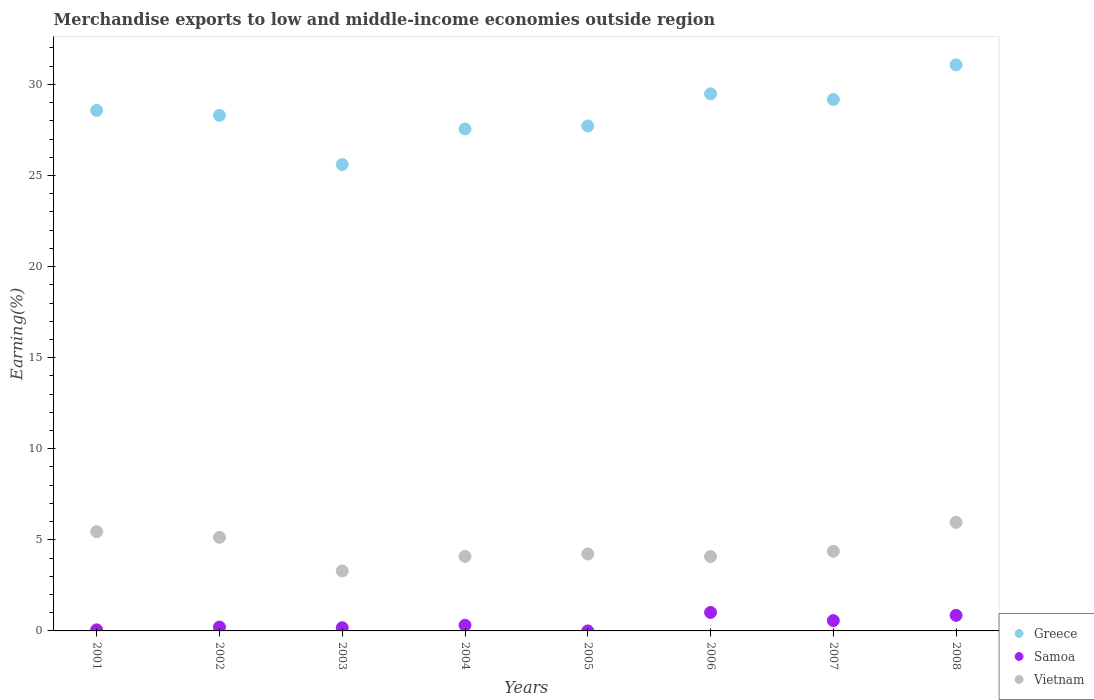How many different coloured dotlines are there?
Give a very brief answer. 3. Is the number of dotlines equal to the number of legend labels?
Keep it short and to the point. Yes. What is the percentage of amount earned from merchandise exports in Vietnam in 2004?
Make the answer very short. 4.09. Across all years, what is the maximum percentage of amount earned from merchandise exports in Greece?
Give a very brief answer. 31.07. Across all years, what is the minimum percentage of amount earned from merchandise exports in Vietnam?
Provide a short and direct response. 3.29. In which year was the percentage of amount earned from merchandise exports in Vietnam minimum?
Provide a succinct answer. 2003. What is the total percentage of amount earned from merchandise exports in Greece in the graph?
Offer a very short reply. 227.48. What is the difference between the percentage of amount earned from merchandise exports in Samoa in 2003 and that in 2007?
Your answer should be compact. -0.39. What is the difference between the percentage of amount earned from merchandise exports in Vietnam in 2004 and the percentage of amount earned from merchandise exports in Samoa in 2002?
Offer a very short reply. 3.88. What is the average percentage of amount earned from merchandise exports in Samoa per year?
Give a very brief answer. 0.4. In the year 2005, what is the difference between the percentage of amount earned from merchandise exports in Samoa and percentage of amount earned from merchandise exports in Vietnam?
Offer a very short reply. -4.22. What is the ratio of the percentage of amount earned from merchandise exports in Samoa in 2006 to that in 2008?
Offer a very short reply. 1.19. Is the difference between the percentage of amount earned from merchandise exports in Samoa in 2005 and 2006 greater than the difference between the percentage of amount earned from merchandise exports in Vietnam in 2005 and 2006?
Your answer should be very brief. No. What is the difference between the highest and the second highest percentage of amount earned from merchandise exports in Samoa?
Provide a succinct answer. 0.16. What is the difference between the highest and the lowest percentage of amount earned from merchandise exports in Vietnam?
Keep it short and to the point. 2.67. Is the sum of the percentage of amount earned from merchandise exports in Greece in 2004 and 2005 greater than the maximum percentage of amount earned from merchandise exports in Samoa across all years?
Offer a very short reply. Yes. Is the percentage of amount earned from merchandise exports in Greece strictly greater than the percentage of amount earned from merchandise exports in Vietnam over the years?
Keep it short and to the point. Yes. Is the percentage of amount earned from merchandise exports in Greece strictly less than the percentage of amount earned from merchandise exports in Samoa over the years?
Offer a very short reply. No. How many dotlines are there?
Your answer should be very brief. 3. How many years are there in the graph?
Offer a very short reply. 8. Does the graph contain any zero values?
Offer a very short reply. No. Does the graph contain grids?
Your answer should be compact. No. Where does the legend appear in the graph?
Your answer should be compact. Bottom right. How are the legend labels stacked?
Your answer should be very brief. Vertical. What is the title of the graph?
Give a very brief answer. Merchandise exports to low and middle-income economies outside region. Does "Serbia" appear as one of the legend labels in the graph?
Give a very brief answer. No. What is the label or title of the X-axis?
Your response must be concise. Years. What is the label or title of the Y-axis?
Make the answer very short. Earning(%). What is the Earning(%) in Greece in 2001?
Ensure brevity in your answer.  28.57. What is the Earning(%) in Samoa in 2001?
Provide a succinct answer. 0.06. What is the Earning(%) of Vietnam in 2001?
Your answer should be compact. 5.45. What is the Earning(%) of Greece in 2002?
Your answer should be compact. 28.3. What is the Earning(%) in Samoa in 2002?
Give a very brief answer. 0.21. What is the Earning(%) of Vietnam in 2002?
Give a very brief answer. 5.14. What is the Earning(%) in Greece in 2003?
Ensure brevity in your answer.  25.6. What is the Earning(%) of Samoa in 2003?
Give a very brief answer. 0.18. What is the Earning(%) of Vietnam in 2003?
Keep it short and to the point. 3.29. What is the Earning(%) in Greece in 2004?
Make the answer very short. 27.56. What is the Earning(%) in Samoa in 2004?
Provide a short and direct response. 0.31. What is the Earning(%) in Vietnam in 2004?
Keep it short and to the point. 4.09. What is the Earning(%) of Greece in 2005?
Provide a succinct answer. 27.72. What is the Earning(%) in Samoa in 2005?
Provide a short and direct response. 4.29047548765544e-6. What is the Earning(%) of Vietnam in 2005?
Give a very brief answer. 4.22. What is the Earning(%) of Greece in 2006?
Make the answer very short. 29.48. What is the Earning(%) in Samoa in 2006?
Your answer should be compact. 1.01. What is the Earning(%) in Vietnam in 2006?
Your answer should be very brief. 4.08. What is the Earning(%) of Greece in 2007?
Keep it short and to the point. 29.17. What is the Earning(%) of Samoa in 2007?
Offer a very short reply. 0.57. What is the Earning(%) in Vietnam in 2007?
Offer a terse response. 4.37. What is the Earning(%) of Greece in 2008?
Your answer should be very brief. 31.07. What is the Earning(%) in Samoa in 2008?
Ensure brevity in your answer.  0.86. What is the Earning(%) of Vietnam in 2008?
Keep it short and to the point. 5.96. Across all years, what is the maximum Earning(%) of Greece?
Keep it short and to the point. 31.07. Across all years, what is the maximum Earning(%) in Samoa?
Make the answer very short. 1.01. Across all years, what is the maximum Earning(%) of Vietnam?
Your answer should be very brief. 5.96. Across all years, what is the minimum Earning(%) in Greece?
Provide a succinct answer. 25.6. Across all years, what is the minimum Earning(%) in Samoa?
Offer a terse response. 4.29047548765544e-6. Across all years, what is the minimum Earning(%) of Vietnam?
Offer a very short reply. 3.29. What is the total Earning(%) of Greece in the graph?
Make the answer very short. 227.48. What is the total Earning(%) of Samoa in the graph?
Your response must be concise. 3.2. What is the total Earning(%) of Vietnam in the graph?
Keep it short and to the point. 36.6. What is the difference between the Earning(%) in Greece in 2001 and that in 2002?
Your answer should be very brief. 0.27. What is the difference between the Earning(%) in Samoa in 2001 and that in 2002?
Your response must be concise. -0.15. What is the difference between the Earning(%) of Vietnam in 2001 and that in 2002?
Give a very brief answer. 0.31. What is the difference between the Earning(%) of Greece in 2001 and that in 2003?
Provide a short and direct response. 2.97. What is the difference between the Earning(%) in Samoa in 2001 and that in 2003?
Your answer should be very brief. -0.12. What is the difference between the Earning(%) of Vietnam in 2001 and that in 2003?
Keep it short and to the point. 2.16. What is the difference between the Earning(%) of Greece in 2001 and that in 2004?
Your response must be concise. 1.02. What is the difference between the Earning(%) of Samoa in 2001 and that in 2004?
Ensure brevity in your answer.  -0.25. What is the difference between the Earning(%) of Vietnam in 2001 and that in 2004?
Give a very brief answer. 1.36. What is the difference between the Earning(%) of Greece in 2001 and that in 2005?
Provide a short and direct response. 0.85. What is the difference between the Earning(%) in Samoa in 2001 and that in 2005?
Ensure brevity in your answer.  0.06. What is the difference between the Earning(%) in Vietnam in 2001 and that in 2005?
Give a very brief answer. 1.22. What is the difference between the Earning(%) of Greece in 2001 and that in 2006?
Your response must be concise. -0.91. What is the difference between the Earning(%) in Samoa in 2001 and that in 2006?
Provide a succinct answer. -0.96. What is the difference between the Earning(%) in Vietnam in 2001 and that in 2006?
Your answer should be compact. 1.37. What is the difference between the Earning(%) in Greece in 2001 and that in 2007?
Your answer should be very brief. -0.6. What is the difference between the Earning(%) of Samoa in 2001 and that in 2007?
Your answer should be compact. -0.51. What is the difference between the Earning(%) in Vietnam in 2001 and that in 2007?
Your answer should be compact. 1.08. What is the difference between the Earning(%) in Greece in 2001 and that in 2008?
Offer a terse response. -2.5. What is the difference between the Earning(%) in Samoa in 2001 and that in 2008?
Provide a succinct answer. -0.8. What is the difference between the Earning(%) of Vietnam in 2001 and that in 2008?
Your response must be concise. -0.51. What is the difference between the Earning(%) of Greece in 2002 and that in 2003?
Ensure brevity in your answer.  2.7. What is the difference between the Earning(%) of Samoa in 2002 and that in 2003?
Ensure brevity in your answer.  0.04. What is the difference between the Earning(%) in Vietnam in 2002 and that in 2003?
Your answer should be compact. 1.85. What is the difference between the Earning(%) in Greece in 2002 and that in 2004?
Your response must be concise. 0.74. What is the difference between the Earning(%) of Samoa in 2002 and that in 2004?
Your answer should be very brief. -0.1. What is the difference between the Earning(%) of Vietnam in 2002 and that in 2004?
Your answer should be compact. 1.04. What is the difference between the Earning(%) in Greece in 2002 and that in 2005?
Offer a terse response. 0.58. What is the difference between the Earning(%) of Samoa in 2002 and that in 2005?
Make the answer very short. 0.21. What is the difference between the Earning(%) of Vietnam in 2002 and that in 2005?
Make the answer very short. 0.91. What is the difference between the Earning(%) in Greece in 2002 and that in 2006?
Provide a short and direct response. -1.18. What is the difference between the Earning(%) in Samoa in 2002 and that in 2006?
Your answer should be compact. -0.8. What is the difference between the Earning(%) in Vietnam in 2002 and that in 2006?
Your answer should be compact. 1.06. What is the difference between the Earning(%) in Greece in 2002 and that in 2007?
Give a very brief answer. -0.87. What is the difference between the Earning(%) of Samoa in 2002 and that in 2007?
Provide a short and direct response. -0.35. What is the difference between the Earning(%) of Vietnam in 2002 and that in 2007?
Offer a terse response. 0.77. What is the difference between the Earning(%) of Greece in 2002 and that in 2008?
Offer a terse response. -2.77. What is the difference between the Earning(%) of Samoa in 2002 and that in 2008?
Give a very brief answer. -0.64. What is the difference between the Earning(%) of Vietnam in 2002 and that in 2008?
Your answer should be compact. -0.82. What is the difference between the Earning(%) in Greece in 2003 and that in 2004?
Offer a terse response. -1.96. What is the difference between the Earning(%) of Samoa in 2003 and that in 2004?
Ensure brevity in your answer.  -0.14. What is the difference between the Earning(%) in Vietnam in 2003 and that in 2004?
Offer a very short reply. -0.8. What is the difference between the Earning(%) of Greece in 2003 and that in 2005?
Provide a short and direct response. -2.12. What is the difference between the Earning(%) in Samoa in 2003 and that in 2005?
Offer a very short reply. 0.18. What is the difference between the Earning(%) in Vietnam in 2003 and that in 2005?
Give a very brief answer. -0.93. What is the difference between the Earning(%) in Greece in 2003 and that in 2006?
Offer a terse response. -3.88. What is the difference between the Earning(%) in Samoa in 2003 and that in 2006?
Provide a short and direct response. -0.84. What is the difference between the Earning(%) in Vietnam in 2003 and that in 2006?
Your response must be concise. -0.79. What is the difference between the Earning(%) of Greece in 2003 and that in 2007?
Provide a succinct answer. -3.57. What is the difference between the Earning(%) in Samoa in 2003 and that in 2007?
Keep it short and to the point. -0.39. What is the difference between the Earning(%) of Vietnam in 2003 and that in 2007?
Provide a short and direct response. -1.08. What is the difference between the Earning(%) in Greece in 2003 and that in 2008?
Make the answer very short. -5.47. What is the difference between the Earning(%) of Samoa in 2003 and that in 2008?
Your response must be concise. -0.68. What is the difference between the Earning(%) in Vietnam in 2003 and that in 2008?
Provide a succinct answer. -2.67. What is the difference between the Earning(%) in Greece in 2004 and that in 2005?
Your answer should be very brief. -0.16. What is the difference between the Earning(%) in Samoa in 2004 and that in 2005?
Provide a short and direct response. 0.31. What is the difference between the Earning(%) of Vietnam in 2004 and that in 2005?
Your answer should be compact. -0.13. What is the difference between the Earning(%) in Greece in 2004 and that in 2006?
Your response must be concise. -1.93. What is the difference between the Earning(%) in Samoa in 2004 and that in 2006?
Your answer should be compact. -0.7. What is the difference between the Earning(%) of Vietnam in 2004 and that in 2006?
Give a very brief answer. 0.01. What is the difference between the Earning(%) in Greece in 2004 and that in 2007?
Your answer should be compact. -1.62. What is the difference between the Earning(%) of Samoa in 2004 and that in 2007?
Ensure brevity in your answer.  -0.25. What is the difference between the Earning(%) in Vietnam in 2004 and that in 2007?
Offer a terse response. -0.28. What is the difference between the Earning(%) of Greece in 2004 and that in 2008?
Your answer should be compact. -3.51. What is the difference between the Earning(%) in Samoa in 2004 and that in 2008?
Give a very brief answer. -0.54. What is the difference between the Earning(%) in Vietnam in 2004 and that in 2008?
Make the answer very short. -1.87. What is the difference between the Earning(%) in Greece in 2005 and that in 2006?
Offer a terse response. -1.77. What is the difference between the Earning(%) of Samoa in 2005 and that in 2006?
Your answer should be compact. -1.01. What is the difference between the Earning(%) of Vietnam in 2005 and that in 2006?
Your answer should be compact. 0.14. What is the difference between the Earning(%) of Greece in 2005 and that in 2007?
Provide a short and direct response. -1.45. What is the difference between the Earning(%) in Samoa in 2005 and that in 2007?
Ensure brevity in your answer.  -0.57. What is the difference between the Earning(%) in Vietnam in 2005 and that in 2007?
Provide a short and direct response. -0.15. What is the difference between the Earning(%) of Greece in 2005 and that in 2008?
Offer a very short reply. -3.35. What is the difference between the Earning(%) in Samoa in 2005 and that in 2008?
Offer a very short reply. -0.86. What is the difference between the Earning(%) of Vietnam in 2005 and that in 2008?
Ensure brevity in your answer.  -1.73. What is the difference between the Earning(%) of Greece in 2006 and that in 2007?
Give a very brief answer. 0.31. What is the difference between the Earning(%) in Samoa in 2006 and that in 2007?
Ensure brevity in your answer.  0.45. What is the difference between the Earning(%) of Vietnam in 2006 and that in 2007?
Ensure brevity in your answer.  -0.29. What is the difference between the Earning(%) in Greece in 2006 and that in 2008?
Your answer should be very brief. -1.59. What is the difference between the Earning(%) of Samoa in 2006 and that in 2008?
Offer a very short reply. 0.16. What is the difference between the Earning(%) in Vietnam in 2006 and that in 2008?
Keep it short and to the point. -1.88. What is the difference between the Earning(%) of Greece in 2007 and that in 2008?
Your answer should be very brief. -1.9. What is the difference between the Earning(%) of Samoa in 2007 and that in 2008?
Offer a terse response. -0.29. What is the difference between the Earning(%) in Vietnam in 2007 and that in 2008?
Ensure brevity in your answer.  -1.59. What is the difference between the Earning(%) in Greece in 2001 and the Earning(%) in Samoa in 2002?
Your answer should be very brief. 28.36. What is the difference between the Earning(%) in Greece in 2001 and the Earning(%) in Vietnam in 2002?
Make the answer very short. 23.43. What is the difference between the Earning(%) of Samoa in 2001 and the Earning(%) of Vietnam in 2002?
Keep it short and to the point. -5.08. What is the difference between the Earning(%) of Greece in 2001 and the Earning(%) of Samoa in 2003?
Give a very brief answer. 28.4. What is the difference between the Earning(%) in Greece in 2001 and the Earning(%) in Vietnam in 2003?
Provide a short and direct response. 25.28. What is the difference between the Earning(%) in Samoa in 2001 and the Earning(%) in Vietnam in 2003?
Offer a very short reply. -3.23. What is the difference between the Earning(%) of Greece in 2001 and the Earning(%) of Samoa in 2004?
Give a very brief answer. 28.26. What is the difference between the Earning(%) of Greece in 2001 and the Earning(%) of Vietnam in 2004?
Make the answer very short. 24.48. What is the difference between the Earning(%) of Samoa in 2001 and the Earning(%) of Vietnam in 2004?
Provide a succinct answer. -4.03. What is the difference between the Earning(%) of Greece in 2001 and the Earning(%) of Samoa in 2005?
Provide a short and direct response. 28.57. What is the difference between the Earning(%) in Greece in 2001 and the Earning(%) in Vietnam in 2005?
Make the answer very short. 24.35. What is the difference between the Earning(%) in Samoa in 2001 and the Earning(%) in Vietnam in 2005?
Make the answer very short. -4.17. What is the difference between the Earning(%) of Greece in 2001 and the Earning(%) of Samoa in 2006?
Offer a very short reply. 27.56. What is the difference between the Earning(%) of Greece in 2001 and the Earning(%) of Vietnam in 2006?
Make the answer very short. 24.49. What is the difference between the Earning(%) in Samoa in 2001 and the Earning(%) in Vietnam in 2006?
Keep it short and to the point. -4.02. What is the difference between the Earning(%) in Greece in 2001 and the Earning(%) in Samoa in 2007?
Offer a very short reply. 28.01. What is the difference between the Earning(%) of Greece in 2001 and the Earning(%) of Vietnam in 2007?
Give a very brief answer. 24.2. What is the difference between the Earning(%) in Samoa in 2001 and the Earning(%) in Vietnam in 2007?
Keep it short and to the point. -4.31. What is the difference between the Earning(%) of Greece in 2001 and the Earning(%) of Samoa in 2008?
Provide a short and direct response. 27.72. What is the difference between the Earning(%) of Greece in 2001 and the Earning(%) of Vietnam in 2008?
Your answer should be very brief. 22.61. What is the difference between the Earning(%) in Samoa in 2001 and the Earning(%) in Vietnam in 2008?
Your response must be concise. -5.9. What is the difference between the Earning(%) of Greece in 2002 and the Earning(%) of Samoa in 2003?
Your answer should be very brief. 28.13. What is the difference between the Earning(%) in Greece in 2002 and the Earning(%) in Vietnam in 2003?
Keep it short and to the point. 25.01. What is the difference between the Earning(%) of Samoa in 2002 and the Earning(%) of Vietnam in 2003?
Keep it short and to the point. -3.08. What is the difference between the Earning(%) of Greece in 2002 and the Earning(%) of Samoa in 2004?
Give a very brief answer. 27.99. What is the difference between the Earning(%) in Greece in 2002 and the Earning(%) in Vietnam in 2004?
Your response must be concise. 24.21. What is the difference between the Earning(%) of Samoa in 2002 and the Earning(%) of Vietnam in 2004?
Your answer should be compact. -3.88. What is the difference between the Earning(%) in Greece in 2002 and the Earning(%) in Samoa in 2005?
Give a very brief answer. 28.3. What is the difference between the Earning(%) of Greece in 2002 and the Earning(%) of Vietnam in 2005?
Your response must be concise. 24.08. What is the difference between the Earning(%) of Samoa in 2002 and the Earning(%) of Vietnam in 2005?
Your answer should be compact. -4.01. What is the difference between the Earning(%) in Greece in 2002 and the Earning(%) in Samoa in 2006?
Provide a succinct answer. 27.29. What is the difference between the Earning(%) in Greece in 2002 and the Earning(%) in Vietnam in 2006?
Give a very brief answer. 24.22. What is the difference between the Earning(%) of Samoa in 2002 and the Earning(%) of Vietnam in 2006?
Offer a terse response. -3.87. What is the difference between the Earning(%) in Greece in 2002 and the Earning(%) in Samoa in 2007?
Keep it short and to the point. 27.74. What is the difference between the Earning(%) in Greece in 2002 and the Earning(%) in Vietnam in 2007?
Offer a terse response. 23.93. What is the difference between the Earning(%) in Samoa in 2002 and the Earning(%) in Vietnam in 2007?
Give a very brief answer. -4.16. What is the difference between the Earning(%) in Greece in 2002 and the Earning(%) in Samoa in 2008?
Your answer should be very brief. 27.45. What is the difference between the Earning(%) in Greece in 2002 and the Earning(%) in Vietnam in 2008?
Your response must be concise. 22.34. What is the difference between the Earning(%) in Samoa in 2002 and the Earning(%) in Vietnam in 2008?
Offer a terse response. -5.74. What is the difference between the Earning(%) in Greece in 2003 and the Earning(%) in Samoa in 2004?
Ensure brevity in your answer.  25.29. What is the difference between the Earning(%) of Greece in 2003 and the Earning(%) of Vietnam in 2004?
Offer a very short reply. 21.51. What is the difference between the Earning(%) of Samoa in 2003 and the Earning(%) of Vietnam in 2004?
Ensure brevity in your answer.  -3.92. What is the difference between the Earning(%) in Greece in 2003 and the Earning(%) in Samoa in 2005?
Offer a very short reply. 25.6. What is the difference between the Earning(%) in Greece in 2003 and the Earning(%) in Vietnam in 2005?
Provide a succinct answer. 21.38. What is the difference between the Earning(%) in Samoa in 2003 and the Earning(%) in Vietnam in 2005?
Offer a very short reply. -4.05. What is the difference between the Earning(%) in Greece in 2003 and the Earning(%) in Samoa in 2006?
Make the answer very short. 24.59. What is the difference between the Earning(%) of Greece in 2003 and the Earning(%) of Vietnam in 2006?
Ensure brevity in your answer.  21.52. What is the difference between the Earning(%) of Samoa in 2003 and the Earning(%) of Vietnam in 2006?
Your response must be concise. -3.9. What is the difference between the Earning(%) of Greece in 2003 and the Earning(%) of Samoa in 2007?
Keep it short and to the point. 25.04. What is the difference between the Earning(%) in Greece in 2003 and the Earning(%) in Vietnam in 2007?
Keep it short and to the point. 21.23. What is the difference between the Earning(%) in Samoa in 2003 and the Earning(%) in Vietnam in 2007?
Your answer should be very brief. -4.2. What is the difference between the Earning(%) in Greece in 2003 and the Earning(%) in Samoa in 2008?
Make the answer very short. 24.75. What is the difference between the Earning(%) of Greece in 2003 and the Earning(%) of Vietnam in 2008?
Ensure brevity in your answer.  19.64. What is the difference between the Earning(%) of Samoa in 2003 and the Earning(%) of Vietnam in 2008?
Your response must be concise. -5.78. What is the difference between the Earning(%) in Greece in 2004 and the Earning(%) in Samoa in 2005?
Give a very brief answer. 27.56. What is the difference between the Earning(%) of Greece in 2004 and the Earning(%) of Vietnam in 2005?
Provide a short and direct response. 23.33. What is the difference between the Earning(%) of Samoa in 2004 and the Earning(%) of Vietnam in 2005?
Provide a short and direct response. -3.91. What is the difference between the Earning(%) of Greece in 2004 and the Earning(%) of Samoa in 2006?
Ensure brevity in your answer.  26.54. What is the difference between the Earning(%) in Greece in 2004 and the Earning(%) in Vietnam in 2006?
Your response must be concise. 23.48. What is the difference between the Earning(%) of Samoa in 2004 and the Earning(%) of Vietnam in 2006?
Your answer should be compact. -3.77. What is the difference between the Earning(%) of Greece in 2004 and the Earning(%) of Samoa in 2007?
Make the answer very short. 26.99. What is the difference between the Earning(%) in Greece in 2004 and the Earning(%) in Vietnam in 2007?
Your answer should be compact. 23.19. What is the difference between the Earning(%) of Samoa in 2004 and the Earning(%) of Vietnam in 2007?
Offer a very short reply. -4.06. What is the difference between the Earning(%) in Greece in 2004 and the Earning(%) in Samoa in 2008?
Give a very brief answer. 26.7. What is the difference between the Earning(%) of Greece in 2004 and the Earning(%) of Vietnam in 2008?
Your response must be concise. 21.6. What is the difference between the Earning(%) of Samoa in 2004 and the Earning(%) of Vietnam in 2008?
Offer a terse response. -5.65. What is the difference between the Earning(%) in Greece in 2005 and the Earning(%) in Samoa in 2006?
Provide a short and direct response. 26.7. What is the difference between the Earning(%) in Greece in 2005 and the Earning(%) in Vietnam in 2006?
Offer a terse response. 23.64. What is the difference between the Earning(%) in Samoa in 2005 and the Earning(%) in Vietnam in 2006?
Keep it short and to the point. -4.08. What is the difference between the Earning(%) of Greece in 2005 and the Earning(%) of Samoa in 2007?
Offer a terse response. 27.15. What is the difference between the Earning(%) of Greece in 2005 and the Earning(%) of Vietnam in 2007?
Your answer should be compact. 23.35. What is the difference between the Earning(%) in Samoa in 2005 and the Earning(%) in Vietnam in 2007?
Your answer should be compact. -4.37. What is the difference between the Earning(%) of Greece in 2005 and the Earning(%) of Samoa in 2008?
Make the answer very short. 26.86. What is the difference between the Earning(%) of Greece in 2005 and the Earning(%) of Vietnam in 2008?
Your response must be concise. 21.76. What is the difference between the Earning(%) of Samoa in 2005 and the Earning(%) of Vietnam in 2008?
Give a very brief answer. -5.96. What is the difference between the Earning(%) of Greece in 2006 and the Earning(%) of Samoa in 2007?
Offer a terse response. 28.92. What is the difference between the Earning(%) of Greece in 2006 and the Earning(%) of Vietnam in 2007?
Provide a short and direct response. 25.11. What is the difference between the Earning(%) in Samoa in 2006 and the Earning(%) in Vietnam in 2007?
Provide a short and direct response. -3.36. What is the difference between the Earning(%) in Greece in 2006 and the Earning(%) in Samoa in 2008?
Give a very brief answer. 28.63. What is the difference between the Earning(%) of Greece in 2006 and the Earning(%) of Vietnam in 2008?
Provide a succinct answer. 23.53. What is the difference between the Earning(%) of Samoa in 2006 and the Earning(%) of Vietnam in 2008?
Your response must be concise. -4.94. What is the difference between the Earning(%) in Greece in 2007 and the Earning(%) in Samoa in 2008?
Your answer should be compact. 28.32. What is the difference between the Earning(%) of Greece in 2007 and the Earning(%) of Vietnam in 2008?
Offer a very short reply. 23.21. What is the difference between the Earning(%) in Samoa in 2007 and the Earning(%) in Vietnam in 2008?
Offer a terse response. -5.39. What is the average Earning(%) in Greece per year?
Provide a succinct answer. 28.44. What is the average Earning(%) of Samoa per year?
Your answer should be compact. 0.4. What is the average Earning(%) in Vietnam per year?
Offer a very short reply. 4.58. In the year 2001, what is the difference between the Earning(%) of Greece and Earning(%) of Samoa?
Provide a succinct answer. 28.51. In the year 2001, what is the difference between the Earning(%) of Greece and Earning(%) of Vietnam?
Ensure brevity in your answer.  23.12. In the year 2001, what is the difference between the Earning(%) of Samoa and Earning(%) of Vietnam?
Keep it short and to the point. -5.39. In the year 2002, what is the difference between the Earning(%) of Greece and Earning(%) of Samoa?
Provide a succinct answer. 28.09. In the year 2002, what is the difference between the Earning(%) of Greece and Earning(%) of Vietnam?
Keep it short and to the point. 23.16. In the year 2002, what is the difference between the Earning(%) of Samoa and Earning(%) of Vietnam?
Your response must be concise. -4.92. In the year 2003, what is the difference between the Earning(%) in Greece and Earning(%) in Samoa?
Give a very brief answer. 25.43. In the year 2003, what is the difference between the Earning(%) in Greece and Earning(%) in Vietnam?
Keep it short and to the point. 22.31. In the year 2003, what is the difference between the Earning(%) of Samoa and Earning(%) of Vietnam?
Your response must be concise. -3.12. In the year 2004, what is the difference between the Earning(%) of Greece and Earning(%) of Samoa?
Give a very brief answer. 27.24. In the year 2004, what is the difference between the Earning(%) of Greece and Earning(%) of Vietnam?
Offer a terse response. 23.46. In the year 2004, what is the difference between the Earning(%) of Samoa and Earning(%) of Vietnam?
Give a very brief answer. -3.78. In the year 2005, what is the difference between the Earning(%) in Greece and Earning(%) in Samoa?
Offer a terse response. 27.72. In the year 2005, what is the difference between the Earning(%) of Greece and Earning(%) of Vietnam?
Make the answer very short. 23.49. In the year 2005, what is the difference between the Earning(%) in Samoa and Earning(%) in Vietnam?
Give a very brief answer. -4.22. In the year 2006, what is the difference between the Earning(%) in Greece and Earning(%) in Samoa?
Your response must be concise. 28.47. In the year 2006, what is the difference between the Earning(%) of Greece and Earning(%) of Vietnam?
Give a very brief answer. 25.4. In the year 2006, what is the difference between the Earning(%) in Samoa and Earning(%) in Vietnam?
Provide a succinct answer. -3.07. In the year 2007, what is the difference between the Earning(%) in Greece and Earning(%) in Samoa?
Ensure brevity in your answer.  28.61. In the year 2007, what is the difference between the Earning(%) in Greece and Earning(%) in Vietnam?
Offer a very short reply. 24.8. In the year 2007, what is the difference between the Earning(%) of Samoa and Earning(%) of Vietnam?
Ensure brevity in your answer.  -3.8. In the year 2008, what is the difference between the Earning(%) in Greece and Earning(%) in Samoa?
Provide a succinct answer. 30.22. In the year 2008, what is the difference between the Earning(%) of Greece and Earning(%) of Vietnam?
Your answer should be compact. 25.11. In the year 2008, what is the difference between the Earning(%) in Samoa and Earning(%) in Vietnam?
Offer a terse response. -5.1. What is the ratio of the Earning(%) in Greece in 2001 to that in 2002?
Your response must be concise. 1.01. What is the ratio of the Earning(%) of Samoa in 2001 to that in 2002?
Offer a very short reply. 0.28. What is the ratio of the Earning(%) in Vietnam in 2001 to that in 2002?
Your answer should be compact. 1.06. What is the ratio of the Earning(%) in Greece in 2001 to that in 2003?
Your answer should be very brief. 1.12. What is the ratio of the Earning(%) of Samoa in 2001 to that in 2003?
Your response must be concise. 0.34. What is the ratio of the Earning(%) in Vietnam in 2001 to that in 2003?
Provide a short and direct response. 1.66. What is the ratio of the Earning(%) of Greece in 2001 to that in 2004?
Your response must be concise. 1.04. What is the ratio of the Earning(%) of Samoa in 2001 to that in 2004?
Your answer should be compact. 0.19. What is the ratio of the Earning(%) of Vietnam in 2001 to that in 2004?
Provide a short and direct response. 1.33. What is the ratio of the Earning(%) of Greece in 2001 to that in 2005?
Your answer should be compact. 1.03. What is the ratio of the Earning(%) of Samoa in 2001 to that in 2005?
Your answer should be very brief. 1.38e+04. What is the ratio of the Earning(%) in Vietnam in 2001 to that in 2005?
Your response must be concise. 1.29. What is the ratio of the Earning(%) of Greece in 2001 to that in 2006?
Provide a succinct answer. 0.97. What is the ratio of the Earning(%) of Samoa in 2001 to that in 2006?
Provide a succinct answer. 0.06. What is the ratio of the Earning(%) of Vietnam in 2001 to that in 2006?
Your answer should be compact. 1.34. What is the ratio of the Earning(%) in Greece in 2001 to that in 2007?
Give a very brief answer. 0.98. What is the ratio of the Earning(%) in Samoa in 2001 to that in 2007?
Your response must be concise. 0.1. What is the ratio of the Earning(%) of Vietnam in 2001 to that in 2007?
Your answer should be compact. 1.25. What is the ratio of the Earning(%) of Greece in 2001 to that in 2008?
Make the answer very short. 0.92. What is the ratio of the Earning(%) of Samoa in 2001 to that in 2008?
Your answer should be compact. 0.07. What is the ratio of the Earning(%) of Vietnam in 2001 to that in 2008?
Your answer should be compact. 0.91. What is the ratio of the Earning(%) in Greece in 2002 to that in 2003?
Provide a succinct answer. 1.11. What is the ratio of the Earning(%) in Samoa in 2002 to that in 2003?
Your response must be concise. 1.22. What is the ratio of the Earning(%) in Vietnam in 2002 to that in 2003?
Keep it short and to the point. 1.56. What is the ratio of the Earning(%) in Samoa in 2002 to that in 2004?
Your answer should be compact. 0.68. What is the ratio of the Earning(%) in Vietnam in 2002 to that in 2004?
Give a very brief answer. 1.26. What is the ratio of the Earning(%) in Greece in 2002 to that in 2005?
Your answer should be compact. 1.02. What is the ratio of the Earning(%) of Samoa in 2002 to that in 2005?
Your answer should be very brief. 4.99e+04. What is the ratio of the Earning(%) in Vietnam in 2002 to that in 2005?
Keep it short and to the point. 1.22. What is the ratio of the Earning(%) in Greece in 2002 to that in 2006?
Keep it short and to the point. 0.96. What is the ratio of the Earning(%) of Samoa in 2002 to that in 2006?
Offer a terse response. 0.21. What is the ratio of the Earning(%) in Vietnam in 2002 to that in 2006?
Offer a terse response. 1.26. What is the ratio of the Earning(%) of Greece in 2002 to that in 2007?
Ensure brevity in your answer.  0.97. What is the ratio of the Earning(%) of Samoa in 2002 to that in 2007?
Your response must be concise. 0.38. What is the ratio of the Earning(%) in Vietnam in 2002 to that in 2007?
Offer a very short reply. 1.18. What is the ratio of the Earning(%) in Greece in 2002 to that in 2008?
Ensure brevity in your answer.  0.91. What is the ratio of the Earning(%) of Samoa in 2002 to that in 2008?
Your response must be concise. 0.25. What is the ratio of the Earning(%) in Vietnam in 2002 to that in 2008?
Give a very brief answer. 0.86. What is the ratio of the Earning(%) of Greece in 2003 to that in 2004?
Your response must be concise. 0.93. What is the ratio of the Earning(%) in Samoa in 2003 to that in 2004?
Your answer should be compact. 0.56. What is the ratio of the Earning(%) of Vietnam in 2003 to that in 2004?
Keep it short and to the point. 0.8. What is the ratio of the Earning(%) of Greece in 2003 to that in 2005?
Keep it short and to the point. 0.92. What is the ratio of the Earning(%) in Samoa in 2003 to that in 2005?
Your response must be concise. 4.09e+04. What is the ratio of the Earning(%) in Vietnam in 2003 to that in 2005?
Ensure brevity in your answer.  0.78. What is the ratio of the Earning(%) in Greece in 2003 to that in 2006?
Offer a terse response. 0.87. What is the ratio of the Earning(%) of Samoa in 2003 to that in 2006?
Provide a short and direct response. 0.17. What is the ratio of the Earning(%) in Vietnam in 2003 to that in 2006?
Ensure brevity in your answer.  0.81. What is the ratio of the Earning(%) in Greece in 2003 to that in 2007?
Your answer should be very brief. 0.88. What is the ratio of the Earning(%) of Samoa in 2003 to that in 2007?
Offer a terse response. 0.31. What is the ratio of the Earning(%) of Vietnam in 2003 to that in 2007?
Your answer should be compact. 0.75. What is the ratio of the Earning(%) in Greece in 2003 to that in 2008?
Your answer should be very brief. 0.82. What is the ratio of the Earning(%) in Samoa in 2003 to that in 2008?
Make the answer very short. 0.21. What is the ratio of the Earning(%) of Vietnam in 2003 to that in 2008?
Provide a succinct answer. 0.55. What is the ratio of the Earning(%) in Greece in 2004 to that in 2005?
Give a very brief answer. 0.99. What is the ratio of the Earning(%) in Samoa in 2004 to that in 2005?
Provide a short and direct response. 7.30e+04. What is the ratio of the Earning(%) in Greece in 2004 to that in 2006?
Offer a very short reply. 0.93. What is the ratio of the Earning(%) in Samoa in 2004 to that in 2006?
Make the answer very short. 0.31. What is the ratio of the Earning(%) in Greece in 2004 to that in 2007?
Offer a very short reply. 0.94. What is the ratio of the Earning(%) in Samoa in 2004 to that in 2007?
Your response must be concise. 0.55. What is the ratio of the Earning(%) in Vietnam in 2004 to that in 2007?
Offer a very short reply. 0.94. What is the ratio of the Earning(%) in Greece in 2004 to that in 2008?
Your answer should be compact. 0.89. What is the ratio of the Earning(%) of Samoa in 2004 to that in 2008?
Offer a terse response. 0.37. What is the ratio of the Earning(%) in Vietnam in 2004 to that in 2008?
Give a very brief answer. 0.69. What is the ratio of the Earning(%) in Greece in 2005 to that in 2006?
Provide a succinct answer. 0.94. What is the ratio of the Earning(%) of Samoa in 2005 to that in 2006?
Offer a very short reply. 0. What is the ratio of the Earning(%) in Vietnam in 2005 to that in 2006?
Your response must be concise. 1.04. What is the ratio of the Earning(%) of Greece in 2005 to that in 2007?
Offer a very short reply. 0.95. What is the ratio of the Earning(%) in Samoa in 2005 to that in 2007?
Your response must be concise. 0. What is the ratio of the Earning(%) of Vietnam in 2005 to that in 2007?
Keep it short and to the point. 0.97. What is the ratio of the Earning(%) in Greece in 2005 to that in 2008?
Offer a very short reply. 0.89. What is the ratio of the Earning(%) of Vietnam in 2005 to that in 2008?
Keep it short and to the point. 0.71. What is the ratio of the Earning(%) of Greece in 2006 to that in 2007?
Ensure brevity in your answer.  1.01. What is the ratio of the Earning(%) of Samoa in 2006 to that in 2007?
Your answer should be very brief. 1.79. What is the ratio of the Earning(%) of Vietnam in 2006 to that in 2007?
Your response must be concise. 0.93. What is the ratio of the Earning(%) in Greece in 2006 to that in 2008?
Provide a short and direct response. 0.95. What is the ratio of the Earning(%) of Samoa in 2006 to that in 2008?
Your response must be concise. 1.19. What is the ratio of the Earning(%) in Vietnam in 2006 to that in 2008?
Your response must be concise. 0.68. What is the ratio of the Earning(%) of Greece in 2007 to that in 2008?
Offer a terse response. 0.94. What is the ratio of the Earning(%) in Samoa in 2007 to that in 2008?
Your response must be concise. 0.66. What is the ratio of the Earning(%) in Vietnam in 2007 to that in 2008?
Make the answer very short. 0.73. What is the difference between the highest and the second highest Earning(%) of Greece?
Offer a terse response. 1.59. What is the difference between the highest and the second highest Earning(%) of Samoa?
Give a very brief answer. 0.16. What is the difference between the highest and the second highest Earning(%) in Vietnam?
Ensure brevity in your answer.  0.51. What is the difference between the highest and the lowest Earning(%) of Greece?
Offer a terse response. 5.47. What is the difference between the highest and the lowest Earning(%) of Samoa?
Your answer should be compact. 1.01. What is the difference between the highest and the lowest Earning(%) of Vietnam?
Keep it short and to the point. 2.67. 